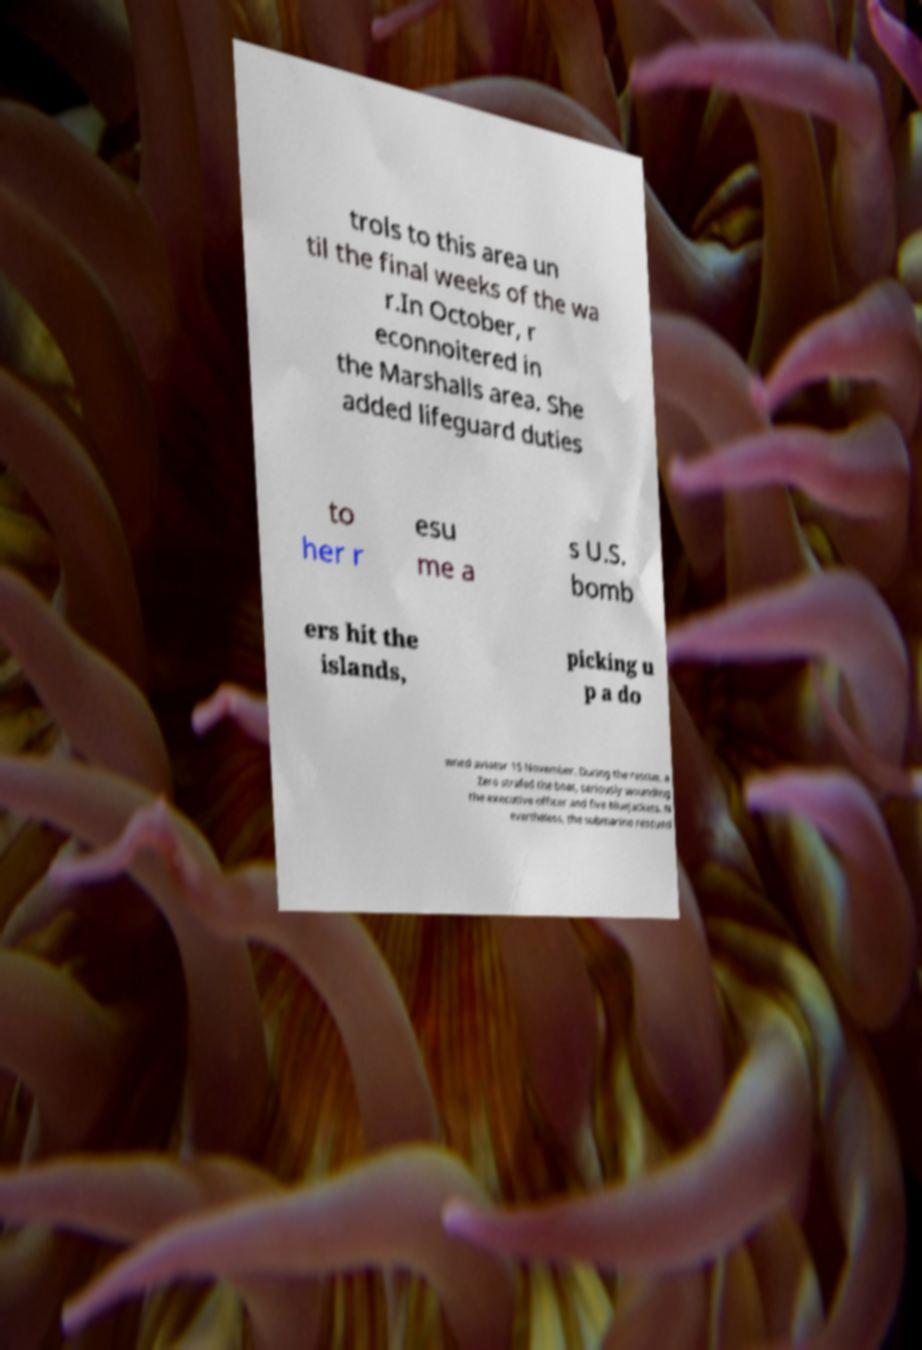For documentation purposes, I need the text within this image transcribed. Could you provide that? trols to this area un til the final weeks of the wa r.In October, r econnoitered in the Marshalls area. She added lifeguard duties to her r esu me a s U.S. bomb ers hit the islands, picking u p a do wned aviator 15 November. During the rescue, a Zero strafed the boat, seriously wounding the executive officer and five bluejackets. N evertheless, the submarine rescued 